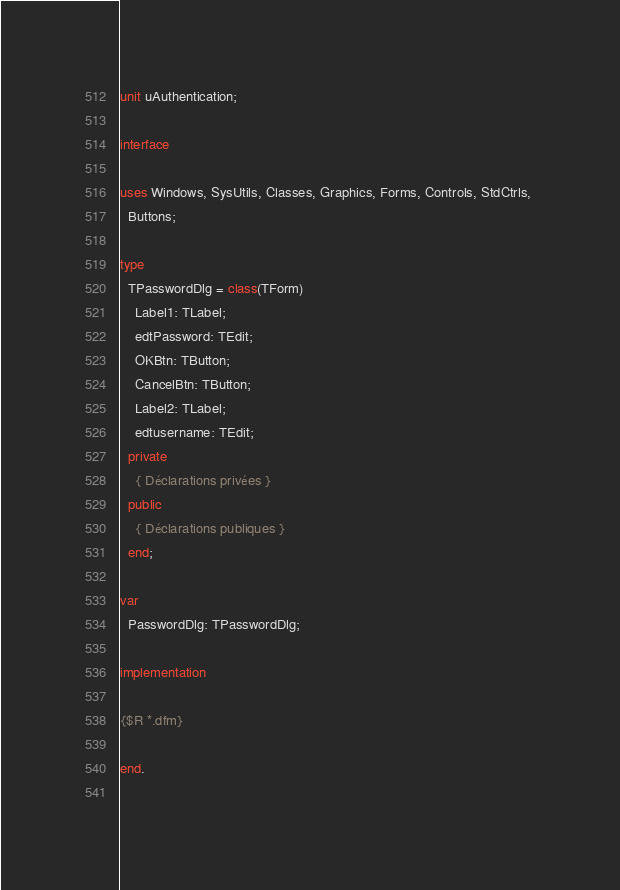<code> <loc_0><loc_0><loc_500><loc_500><_Pascal_>unit uAuthentication;

interface

uses Windows, SysUtils, Classes, Graphics, Forms, Controls, StdCtrls, 
  Buttons;

type
  TPasswordDlg = class(TForm)
    Label1: TLabel;
    edtPassword: TEdit;
    OKBtn: TButton;
    CancelBtn: TButton;
    Label2: TLabel;
    edtusername: TEdit;
  private
    { Déclarations privées }
  public
    { Déclarations publiques }
  end;

var
  PasswordDlg: TPasswordDlg;

implementation

{$R *.dfm}

end.
 
</code> 